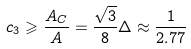Convert formula to latex. <formula><loc_0><loc_0><loc_500><loc_500>c _ { 3 } \geqslant { \frac { A _ { C } } { A } } = { \frac { \sqrt { 3 } } { 8 } } \Delta \approx \frac { 1 } { 2 . 7 7 }</formula> 